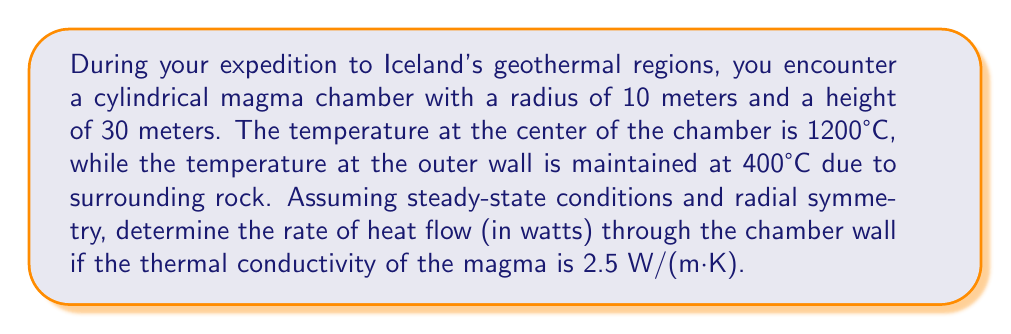Could you help me with this problem? To solve this problem, we'll use the heat equation in cylindrical coordinates for steady-state conditions with radial symmetry:

1) The steady-state heat equation in cylindrical coordinates is:

   $$\frac{1}{r}\frac{d}{dr}\left(r\frac{dT}{dr}\right) = 0$$

2) Integrating once:

   $$r\frac{dT}{dr} = C_1$$

3) Integrating again:

   $$T(r) = C_1 \ln(r) + C_2$$

4) Apply boundary conditions:
   At $r = 0$, $T = 1200°C$
   At $r = 10$ m, $T = 400°C$

5) Solving for constants:
   $1200 = C_2$ (since $\ln(0)$ is undefined)
   $400 = C_1 \ln(10) + 1200$
   $C_1 = \frac{400 - 1200}{\ln(10)} \approx -346.57$

6) The temperature distribution is:

   $$T(r) = -346.57 \ln(r) + 1200$$

7) The heat flow rate is given by Fourier's law:

   $$Q = -k A \frac{dT}{dr}$$

   where $k$ is thermal conductivity, $A$ is surface area.

8) Calculate $\frac{dT}{dr}$:

   $$\frac{dT}{dr} = -\frac{346.57}{r}$$

9) At $r = 10$ m:

   $$\frac{dT}{dr}\bigg|_{r=10} = -34.657 \text{ °C/m}$$

10) Surface area of the cylinder:

    $$A = 2\pi rh = 2\pi(10)(30) = 1884.96 \text{ m}^2$$

11) Calculate heat flow:

    $$Q = -k A \frac{dT}{dr} = -(2.5)(1884.96)(-34.657) = 163,510 \text{ W}$$
Answer: 163,510 W 